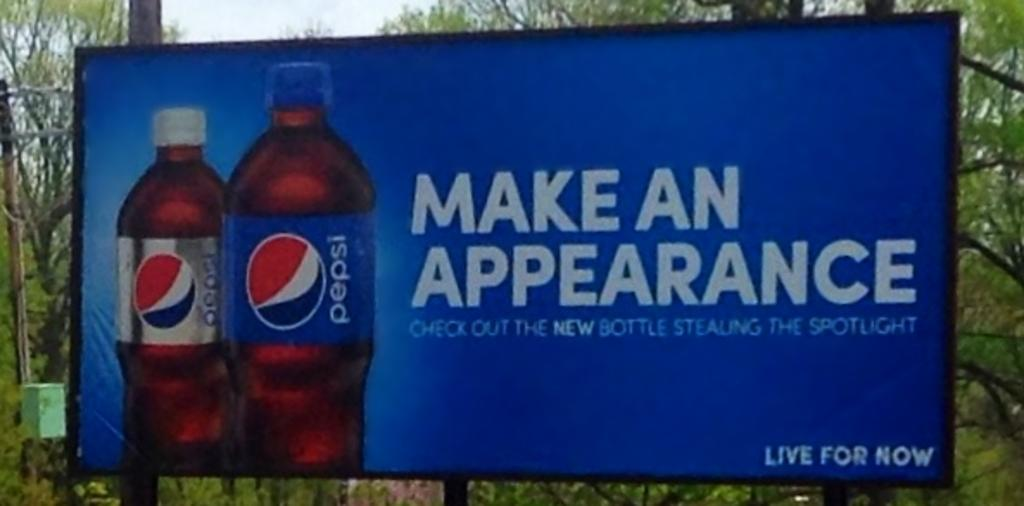Provide a one-sentence caption for the provided image. A large advertising board shows two pepsi bottles and the slogan make an appearance. 